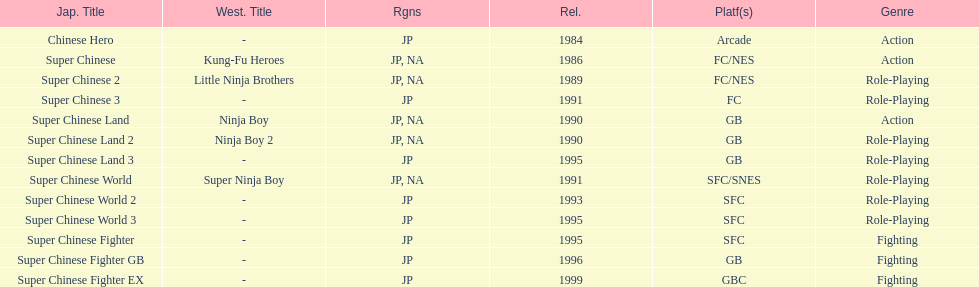How many action games were released in north america? 2. 